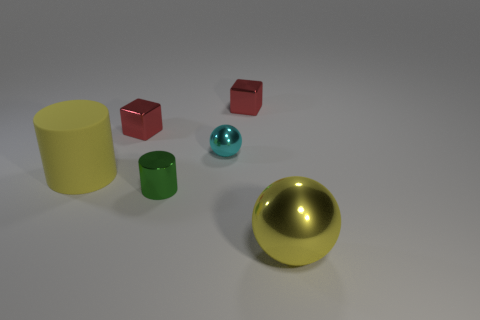How big is the thing that is both to the right of the green thing and in front of the big yellow cylinder?
Give a very brief answer. Large. What is the large yellow thing that is right of the rubber thing made of?
Your answer should be compact. Metal. Is there another big metal object of the same shape as the cyan object?
Your response must be concise. Yes. How many large yellow shiny things are the same shape as the yellow matte thing?
Keep it short and to the point. 0. There is a sphere behind the big yellow shiny thing; does it have the same size as the red thing that is left of the small shiny cylinder?
Ensure brevity in your answer.  Yes. The yellow matte object that is to the left of the cylinder that is in front of the big yellow rubber thing is what shape?
Provide a succinct answer. Cylinder. Is the number of rubber cylinders in front of the big yellow sphere the same as the number of large green metallic balls?
Keep it short and to the point. Yes. There is a small object in front of the cylinder that is on the left side of the tiny red shiny cube to the left of the small cyan metallic thing; what is it made of?
Your response must be concise. Metal. Is there a gray rubber object that has the same size as the cyan shiny thing?
Provide a succinct answer. No. There is a rubber thing; what shape is it?
Offer a terse response. Cylinder. 